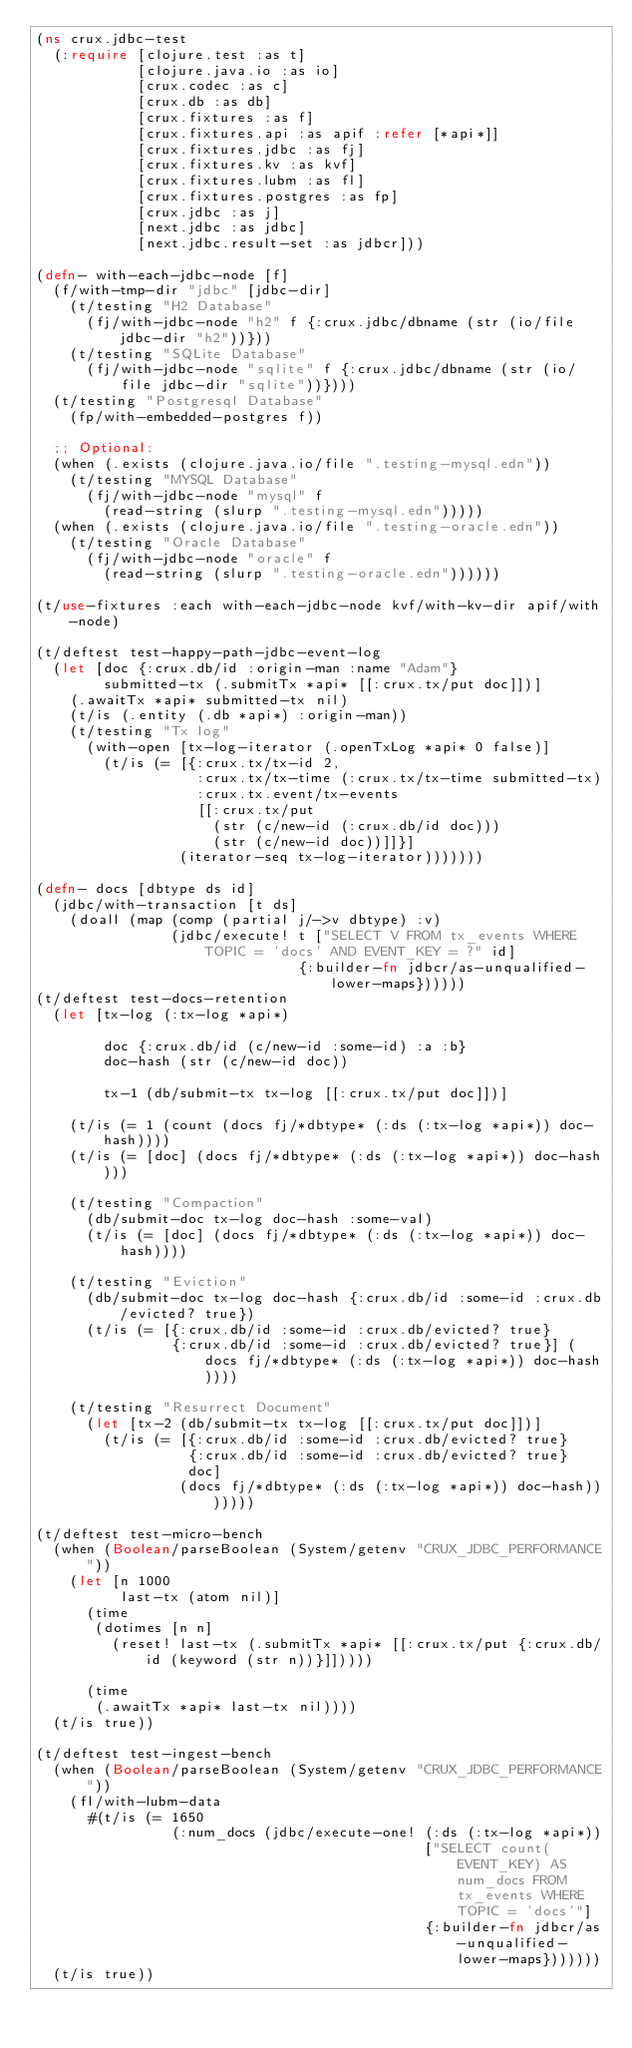<code> <loc_0><loc_0><loc_500><loc_500><_Clojure_>(ns crux.jdbc-test
  (:require [clojure.test :as t]
            [clojure.java.io :as io]
            [crux.codec :as c]
            [crux.db :as db]
            [crux.fixtures :as f]
            [crux.fixtures.api :as apif :refer [*api*]]
            [crux.fixtures.jdbc :as fj]
            [crux.fixtures.kv :as kvf]
            [crux.fixtures.lubm :as fl]
            [crux.fixtures.postgres :as fp]
            [crux.jdbc :as j]
            [next.jdbc :as jdbc]
            [next.jdbc.result-set :as jdbcr]))

(defn- with-each-jdbc-node [f]
  (f/with-tmp-dir "jdbc" [jdbc-dir]
    (t/testing "H2 Database"
      (fj/with-jdbc-node "h2" f {:crux.jdbc/dbname (str (io/file jdbc-dir "h2"))}))
    (t/testing "SQLite Database"
      (fj/with-jdbc-node "sqlite" f {:crux.jdbc/dbname (str (io/file jdbc-dir "sqlite"))})))
  (t/testing "Postgresql Database"
    (fp/with-embedded-postgres f))

  ;; Optional:
  (when (.exists (clojure.java.io/file ".testing-mysql.edn"))
    (t/testing "MYSQL Database"
      (fj/with-jdbc-node "mysql" f
        (read-string (slurp ".testing-mysql.edn")))))
  (when (.exists (clojure.java.io/file ".testing-oracle.edn"))
    (t/testing "Oracle Database"
      (fj/with-jdbc-node "oracle" f
        (read-string (slurp ".testing-oracle.edn"))))))

(t/use-fixtures :each with-each-jdbc-node kvf/with-kv-dir apif/with-node)

(t/deftest test-happy-path-jdbc-event-log
  (let [doc {:crux.db/id :origin-man :name "Adam"}
        submitted-tx (.submitTx *api* [[:crux.tx/put doc]])]
    (.awaitTx *api* submitted-tx nil)
    (t/is (.entity (.db *api*) :origin-man))
    (t/testing "Tx log"
      (with-open [tx-log-iterator (.openTxLog *api* 0 false)]
        (t/is (= [{:crux.tx/tx-id 2,
                   :crux.tx/tx-time (:crux.tx/tx-time submitted-tx)
                   :crux.tx.event/tx-events
                   [[:crux.tx/put
                     (str (c/new-id (:crux.db/id doc)))
                     (str (c/new-id doc))]]}]
                 (iterator-seq tx-log-iterator)))))))

(defn- docs [dbtype ds id]
  (jdbc/with-transaction [t ds]
    (doall (map (comp (partial j/->v dbtype) :v)
                (jdbc/execute! t ["SELECT V FROM tx_events WHERE TOPIC = 'docs' AND EVENT_KEY = ?" id]
                               {:builder-fn jdbcr/as-unqualified-lower-maps})))))
(t/deftest test-docs-retention
  (let [tx-log (:tx-log *api*)

        doc {:crux.db/id (c/new-id :some-id) :a :b}
        doc-hash (str (c/new-id doc))

        tx-1 (db/submit-tx tx-log [[:crux.tx/put doc]])]

    (t/is (= 1 (count (docs fj/*dbtype* (:ds (:tx-log *api*)) doc-hash))))
    (t/is (= [doc] (docs fj/*dbtype* (:ds (:tx-log *api*)) doc-hash)))

    (t/testing "Compaction"
      (db/submit-doc tx-log doc-hash :some-val)
      (t/is (= [doc] (docs fj/*dbtype* (:ds (:tx-log *api*)) doc-hash))))

    (t/testing "Eviction"
      (db/submit-doc tx-log doc-hash {:crux.db/id :some-id :crux.db/evicted? true})
      (t/is (= [{:crux.db/id :some-id :crux.db/evicted? true}
                {:crux.db/id :some-id :crux.db/evicted? true}] (docs fj/*dbtype* (:ds (:tx-log *api*)) doc-hash))))

    (t/testing "Resurrect Document"
      (let [tx-2 (db/submit-tx tx-log [[:crux.tx/put doc]])]
        (t/is (= [{:crux.db/id :some-id :crux.db/evicted? true}
                  {:crux.db/id :some-id :crux.db/evicted? true}
                  doc]
                 (docs fj/*dbtype* (:ds (:tx-log *api*)) doc-hash)))))))

(t/deftest test-micro-bench
  (when (Boolean/parseBoolean (System/getenv "CRUX_JDBC_PERFORMANCE"))
    (let [n 1000
          last-tx (atom nil)]
      (time
       (dotimes [n n]
         (reset! last-tx (.submitTx *api* [[:crux.tx/put {:crux.db/id (keyword (str n))}]]))))

      (time
       (.awaitTx *api* last-tx nil))))
  (t/is true))

(t/deftest test-ingest-bench
  (when (Boolean/parseBoolean (System/getenv "CRUX_JDBC_PERFORMANCE"))
    (fl/with-lubm-data
      #(t/is (= 1650
                (:num_docs (jdbc/execute-one! (:ds (:tx-log *api*))
                                              ["SELECT count(EVENT_KEY) AS num_docs FROM tx_events WHERE TOPIC = 'docs'"]
                                              {:builder-fn jdbcr/as-unqualified-lower-maps}))))))
  (t/is true))
</code> 